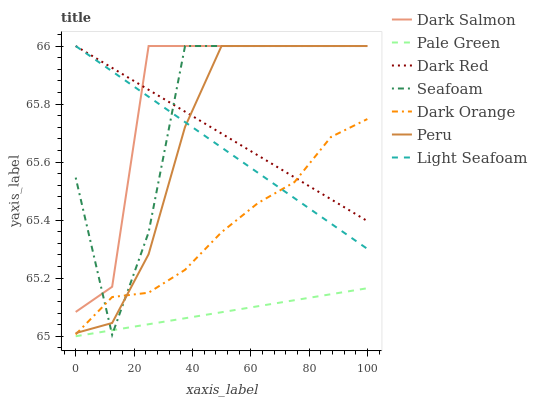Does Pale Green have the minimum area under the curve?
Answer yes or no. Yes. Does Dark Salmon have the maximum area under the curve?
Answer yes or no. Yes. Does Dark Red have the minimum area under the curve?
Answer yes or no. No. Does Dark Red have the maximum area under the curve?
Answer yes or no. No. Is Pale Green the smoothest?
Answer yes or no. Yes. Is Seafoam the roughest?
Answer yes or no. Yes. Is Dark Red the smoothest?
Answer yes or no. No. Is Dark Red the roughest?
Answer yes or no. No. Does Dark Salmon have the lowest value?
Answer yes or no. No. Does Pale Green have the highest value?
Answer yes or no. No. Is Pale Green less than Dark Red?
Answer yes or no. Yes. Is Peru greater than Pale Green?
Answer yes or no. Yes. Does Pale Green intersect Dark Red?
Answer yes or no. No. 